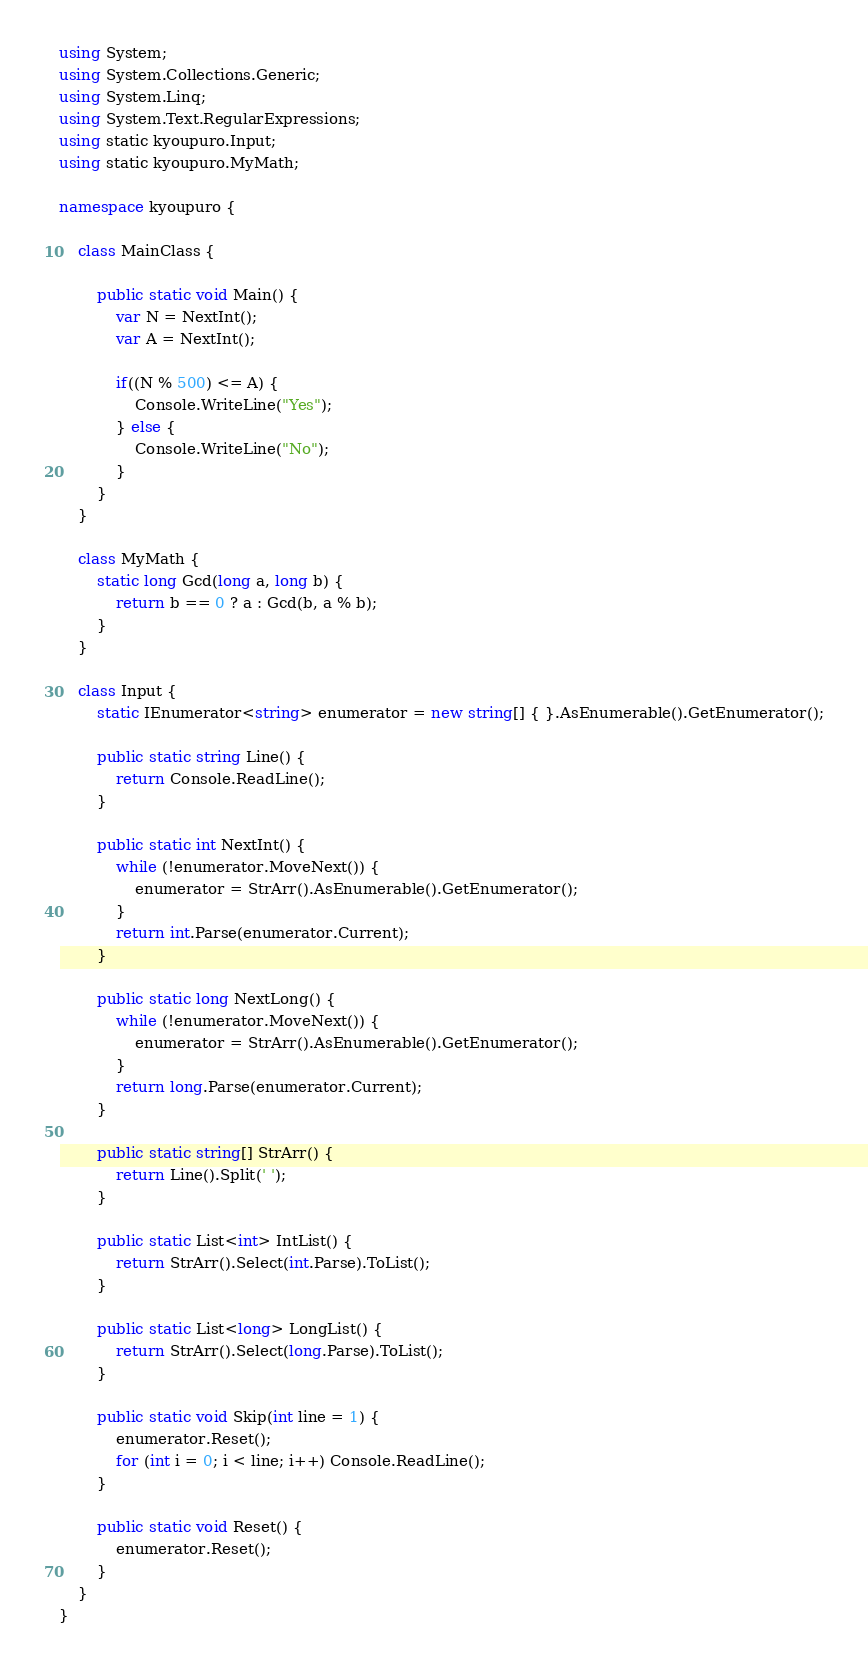Convert code to text. <code><loc_0><loc_0><loc_500><loc_500><_C#_>using System;
using System.Collections.Generic;
using System.Linq;
using System.Text.RegularExpressions;
using static kyoupuro.Input;
using static kyoupuro.MyMath;

namespace kyoupuro {

    class MainClass {

        public static void Main() {
            var N = NextInt();
            var A = NextInt();

            if((N % 500) <= A) {
                Console.WriteLine("Yes");
            } else {
                Console.WriteLine("No");
            }
        }
    }

    class MyMath {
        static long Gcd(long a, long b) {
            return b == 0 ? a : Gcd(b, a % b);
        }
    }

    class Input {
        static IEnumerator<string> enumerator = new string[] { }.AsEnumerable().GetEnumerator();

        public static string Line() {
            return Console.ReadLine();
        }

        public static int NextInt() {
            while (!enumerator.MoveNext()) {
                enumerator = StrArr().AsEnumerable().GetEnumerator();
            }
            return int.Parse(enumerator.Current);
        }

        public static long NextLong() {
            while (!enumerator.MoveNext()) {
                enumerator = StrArr().AsEnumerable().GetEnumerator();
            }
            return long.Parse(enumerator.Current);
        }

        public static string[] StrArr() {
            return Line().Split(' ');
        }

        public static List<int> IntList() {
            return StrArr().Select(int.Parse).ToList();
        }

        public static List<long> LongList() {
            return StrArr().Select(long.Parse).ToList();
        }

        public static void Skip(int line = 1) {
            enumerator.Reset();
            for (int i = 0; i < line; i++) Console.ReadLine();
        }

        public static void Reset() {
            enumerator.Reset();
        }
    }
}</code> 